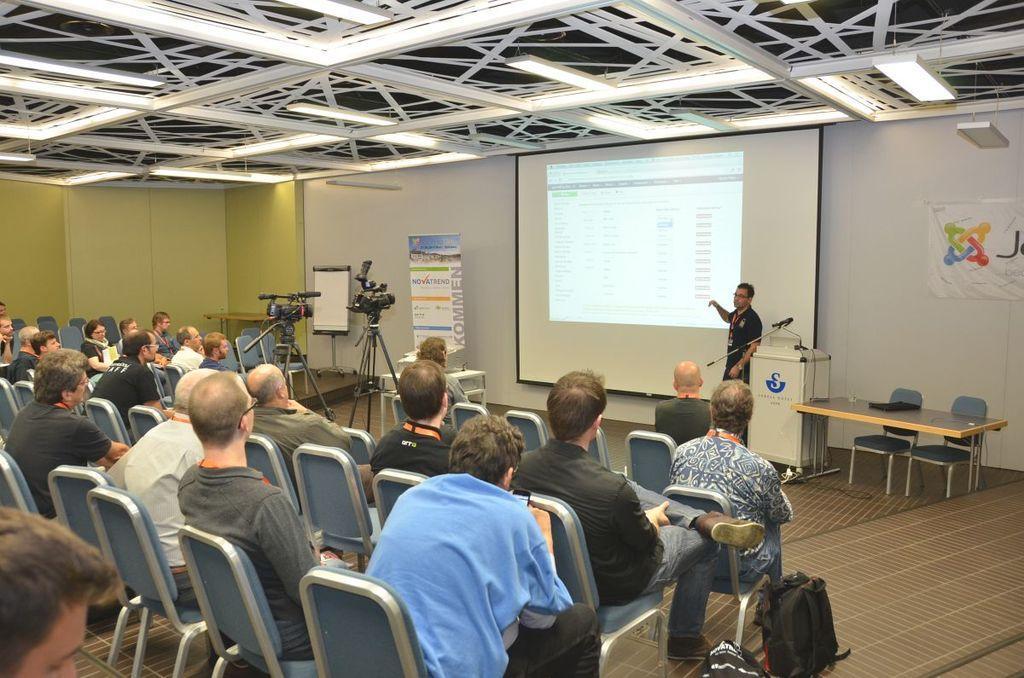Could you give a brief overview of what you see in this image? In this picture there are group of people listening to a man presenting. A screen behind him showing some data on the screen. There are two video cameras in front of the screen recording the session. 